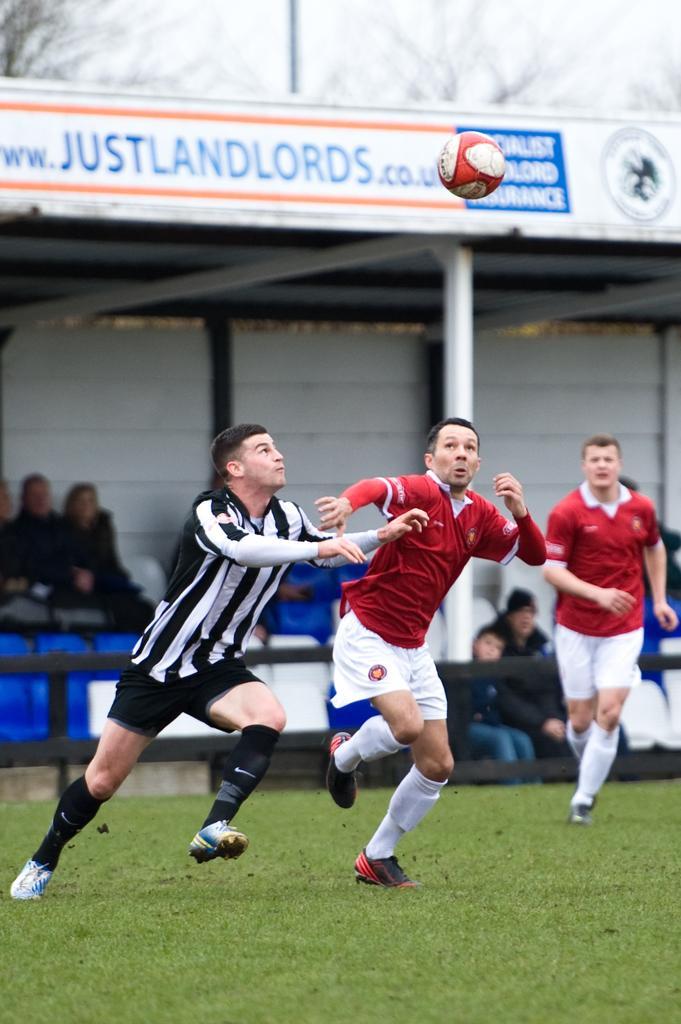How would you summarize this image in a sentence or two? On the left there is a man who is wearing black and white t-shirt, short and shoe. Beside him we can see another man who is wearing a red t-shirt, short and show. On the right there is a man who is running on the ground. Here we can see football. On the bottom we can see grass. On the background we can see some people are sitting on the chair and watching the game. on the top we can see advertisement board. 